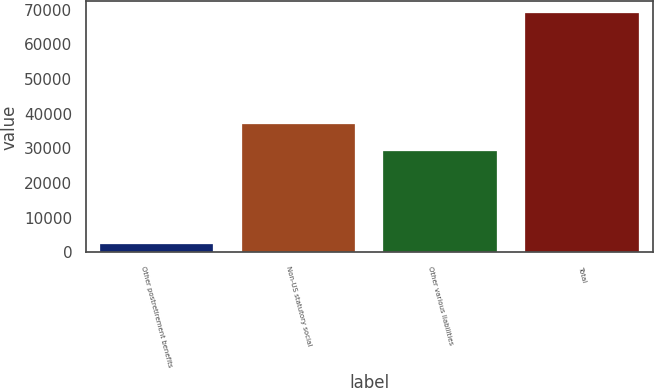<chart> <loc_0><loc_0><loc_500><loc_500><bar_chart><fcel>Other postretirement benefits<fcel>Non-US statutory social<fcel>Other various liabilities<fcel>Total<nl><fcel>2470<fcel>37128<fcel>29382<fcel>68980<nl></chart> 